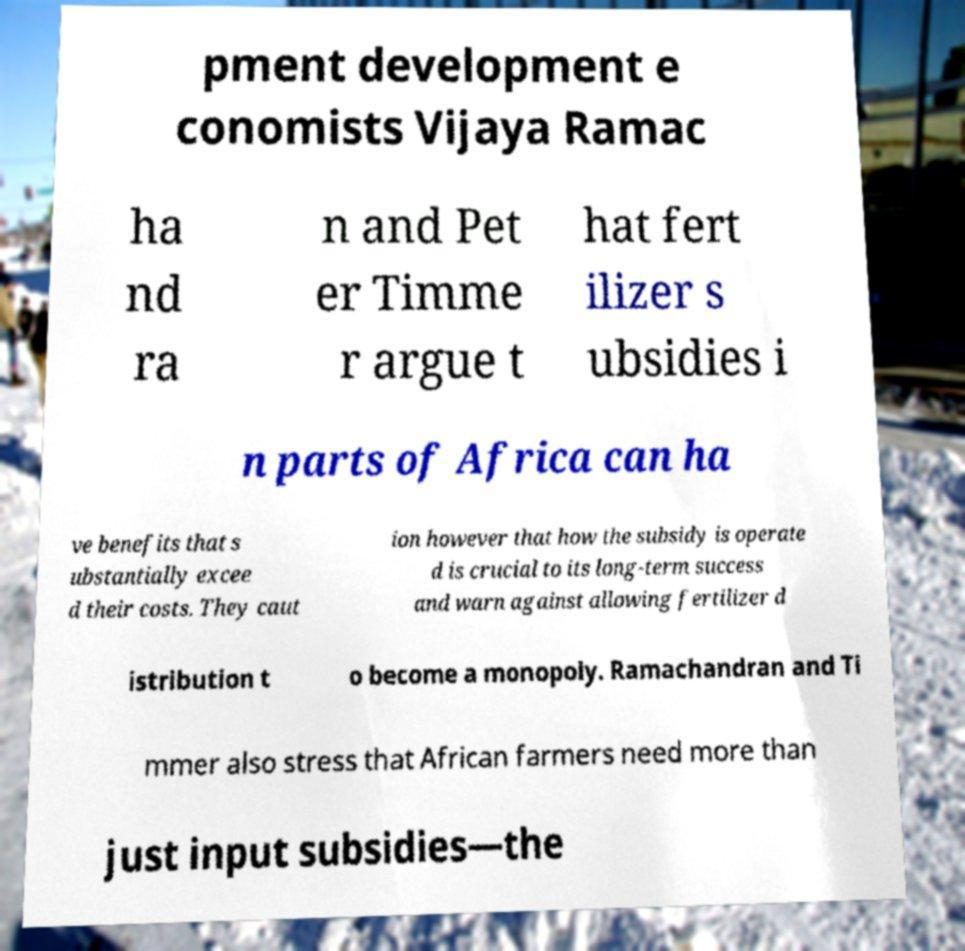For documentation purposes, I need the text within this image transcribed. Could you provide that? pment development e conomists Vijaya Ramac ha nd ra n and Pet er Timme r argue t hat fert ilizer s ubsidies i n parts of Africa can ha ve benefits that s ubstantially excee d their costs. They caut ion however that how the subsidy is operate d is crucial to its long-term success and warn against allowing fertilizer d istribution t o become a monopoly. Ramachandran and Ti mmer also stress that African farmers need more than just input subsidies—the 